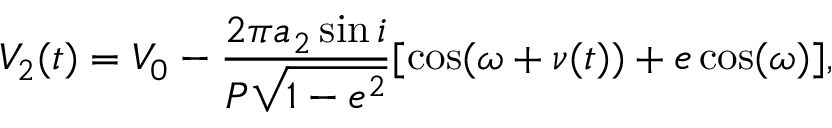Convert formula to latex. <formula><loc_0><loc_0><loc_500><loc_500>V _ { 2 } ( t ) = V _ { 0 } - \frac { 2 \pi a _ { 2 } \sin { i } } { P \sqrt { 1 - e ^ { 2 } } } [ \cos ( \omega + \nu ( t ) ) + e \cos ( \omega ) ] ,</formula> 